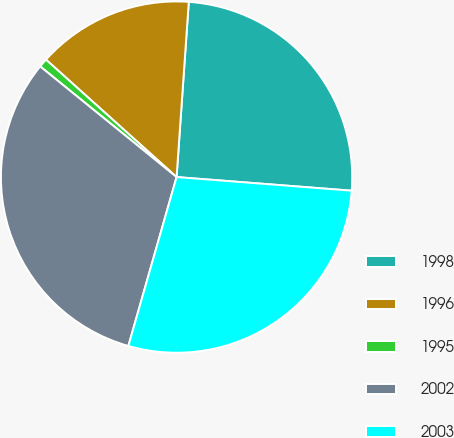Convert chart to OTSL. <chart><loc_0><loc_0><loc_500><loc_500><pie_chart><fcel>1998<fcel>1996<fcel>1995<fcel>2002<fcel>2003<nl><fcel>25.13%<fcel>14.45%<fcel>0.81%<fcel>31.42%<fcel>28.19%<nl></chart> 